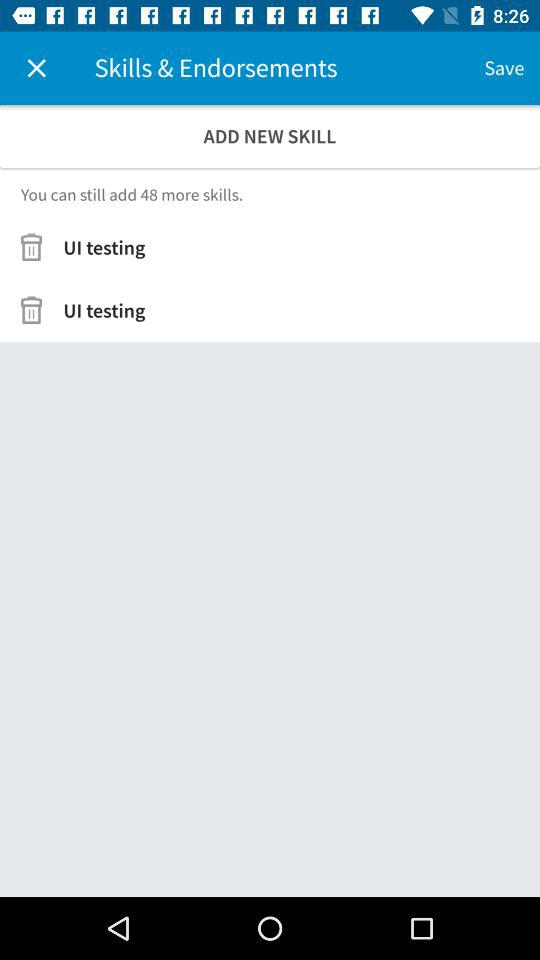How many more skills can be added? There are 48 more skills that can be added. 